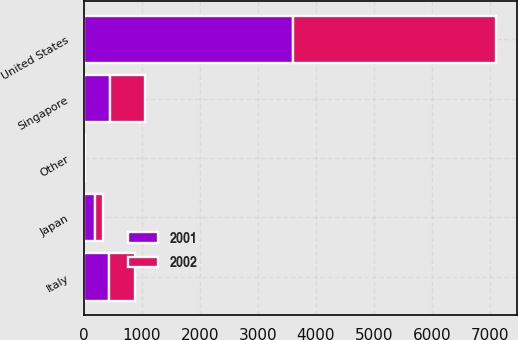Convert chart to OTSL. <chart><loc_0><loc_0><loc_500><loc_500><stacked_bar_chart><ecel><fcel>United States<fcel>Singapore<fcel>Italy<fcel>Japan<fcel>Other<nl><fcel>2001<fcel>3604<fcel>454<fcel>435.2<fcel>191.5<fcel>14.8<nl><fcel>2002<fcel>3502.1<fcel>610.1<fcel>442.3<fcel>133.6<fcel>16<nl></chart> 